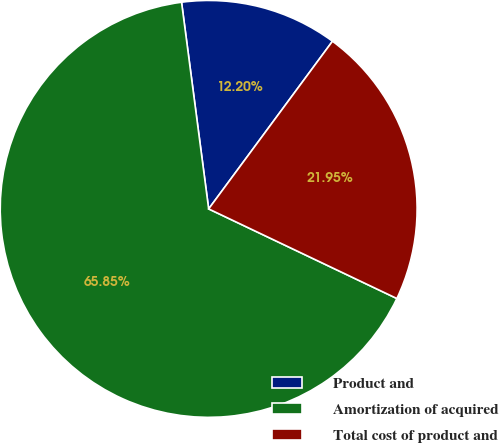Convert chart to OTSL. <chart><loc_0><loc_0><loc_500><loc_500><pie_chart><fcel>Product and<fcel>Amortization of acquired<fcel>Total cost of product and<nl><fcel>12.2%<fcel>65.85%<fcel>21.95%<nl></chart> 